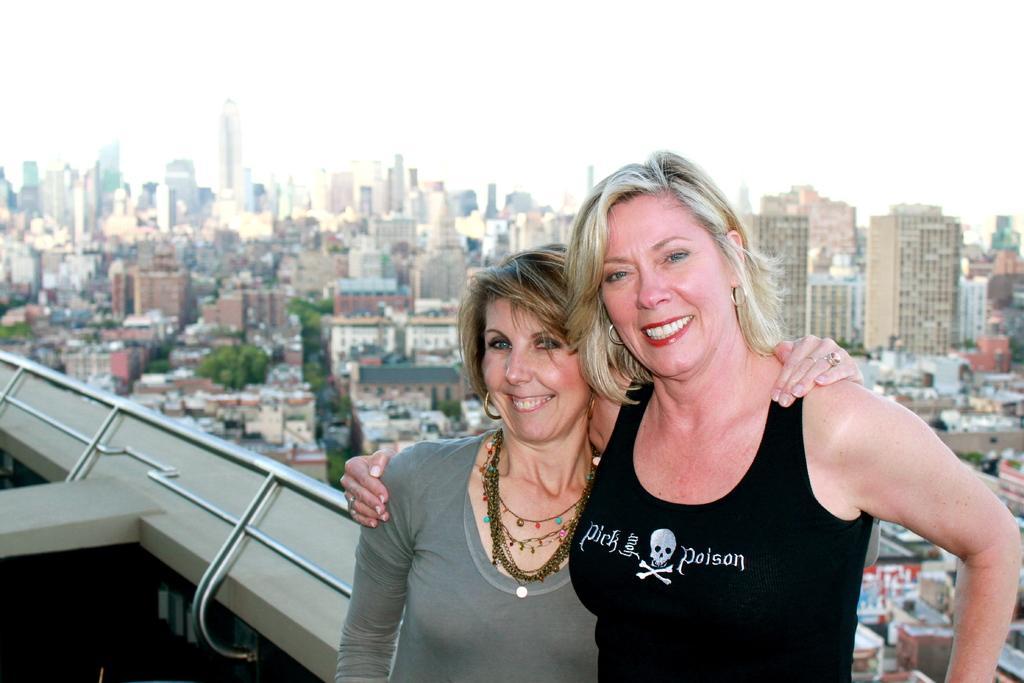How would you summarize this image in a sentence or two? In this image I can see two women in the front and I can also see both of them are smiling. I can also see the left one is wearing necklace and I can see something is written on the right ones dress. In the background I can see railing, number of buildings and number of trees. 